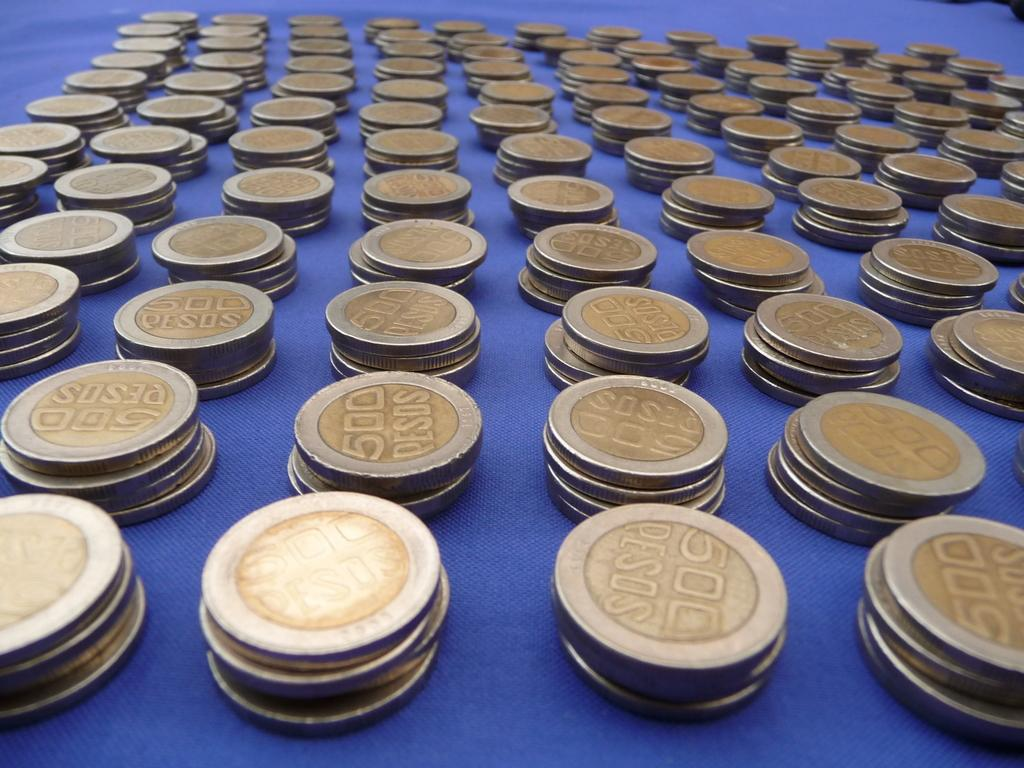<image>
Share a concise interpretation of the image provided. Eleven rows of pesos with 500 written on them are displayed on a blue counter. 